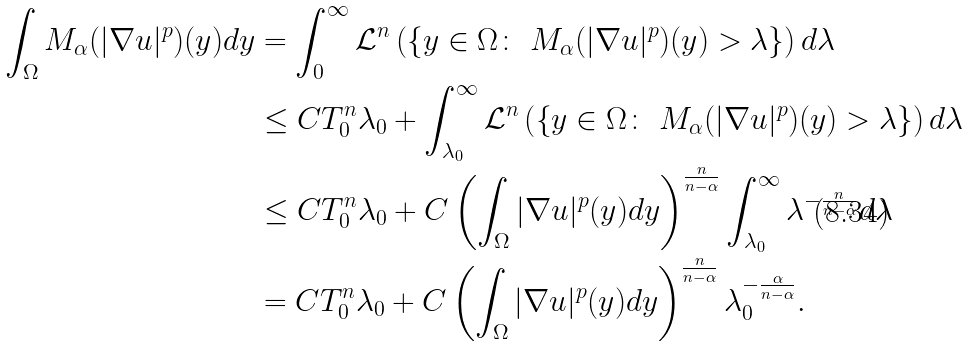Convert formula to latex. <formula><loc_0><loc_0><loc_500><loc_500>\int _ { \Omega } M _ { \alpha } ( | \nabla u | ^ { p } ) ( y ) d y & = \int _ { 0 } ^ { \infty } \mathcal { L } ^ { n } \left ( \left \{ y \in \Omega \colon \ M _ { \alpha } ( | \nabla u | ^ { p } ) ( y ) > \lambda \right \} \right ) d \lambda \\ & \leq C T _ { 0 } ^ { n } \lambda _ { 0 } + \int _ { \lambda _ { 0 } } ^ { \infty } \mathcal { L } ^ { n } \left ( \left \{ y \in \Omega \colon \ M _ { \alpha } ( | \nabla u | ^ { p } ) ( y ) > \lambda \right \} \right ) d \lambda \\ & \leq C T _ { 0 } ^ { n } \lambda _ { 0 } + C \left ( \int _ { \Omega } | \nabla u | ^ { p } ( y ) d y \right ) ^ { \frac { n } { n - \alpha } } \int _ { \lambda _ { 0 } } ^ { \infty } \lambda ^ { - \frac { n } { n - \alpha } } d \lambda \\ & = C T _ { 0 } ^ { n } \lambda _ { 0 } + C \left ( \int _ { \Omega } | \nabla u | ^ { p } ( y ) d y \right ) ^ { \frac { n } { n - \alpha } } \lambda _ { 0 } ^ { - \frac { \alpha } { n - \alpha } } .</formula> 